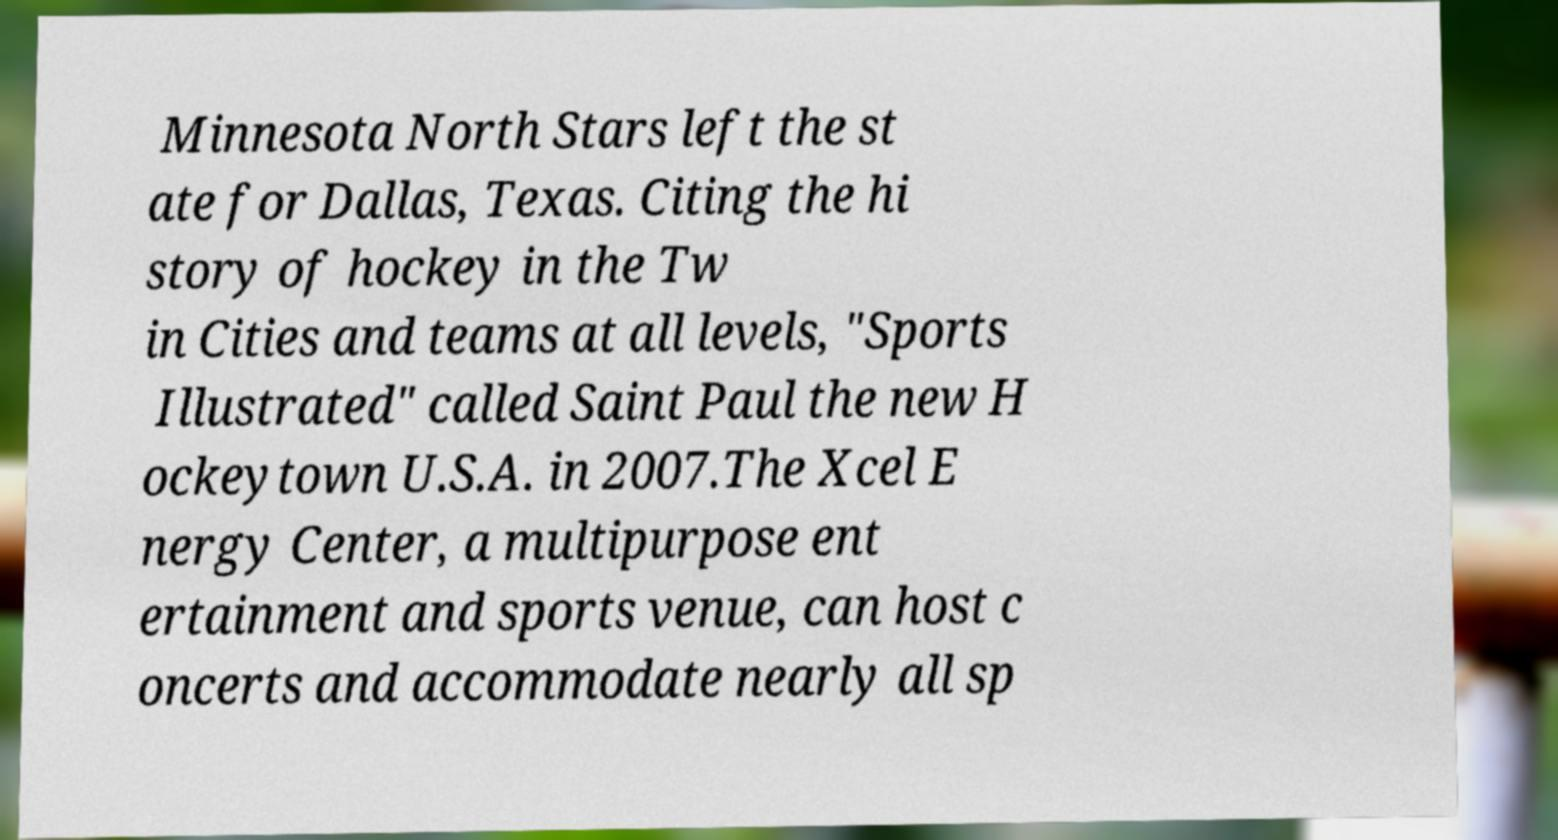Can you accurately transcribe the text from the provided image for me? Minnesota North Stars left the st ate for Dallas, Texas. Citing the hi story of hockey in the Tw in Cities and teams at all levels, "Sports Illustrated" called Saint Paul the new H ockeytown U.S.A. in 2007.The Xcel E nergy Center, a multipurpose ent ertainment and sports venue, can host c oncerts and accommodate nearly all sp 